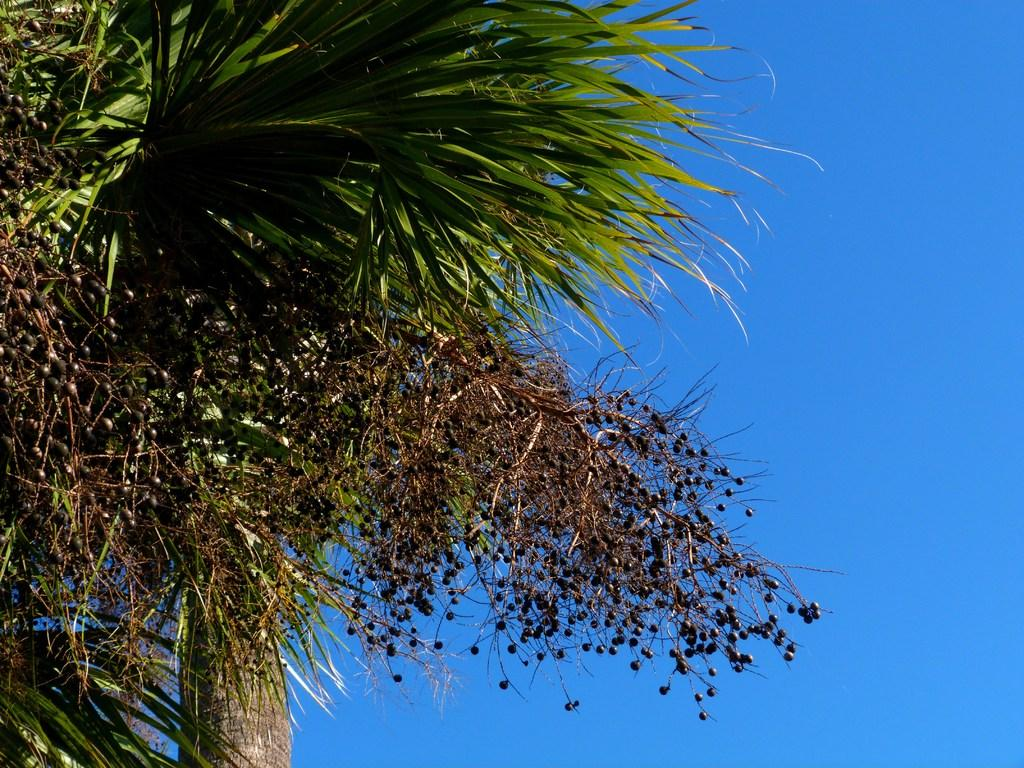What type of vegetation can be seen in the image? There are trees in the image. What part of the natural environment is visible in the image? The sky is visible in the background of the image. What type of quill is being used to write on the tree in the image? There is no quill or writing present in the image; it features trees and the sky. 